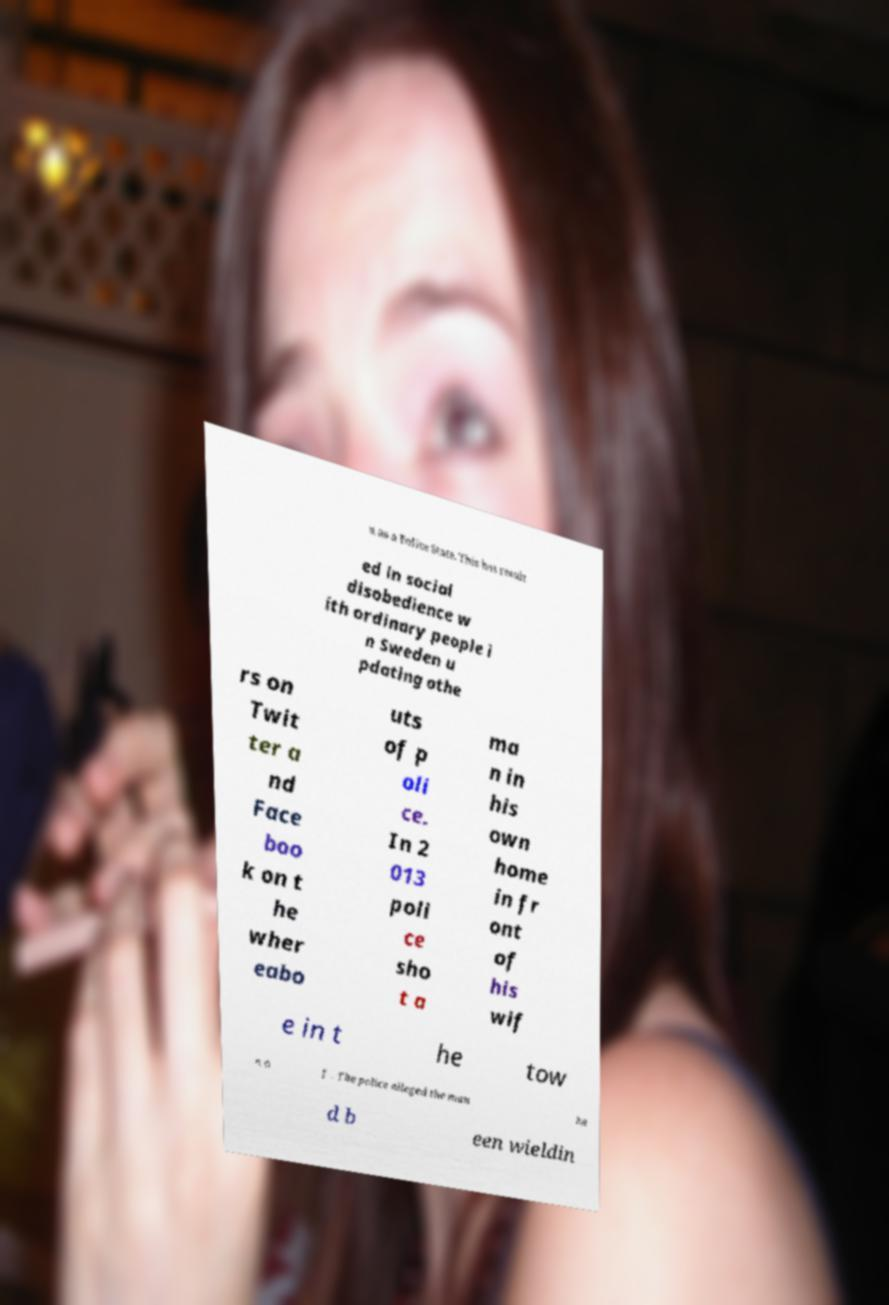Could you extract and type out the text from this image? n as a Police State. This has result ed in social disobedience w ith ordinary people i n Sweden u pdating othe rs on Twit ter a nd Face boo k on t he wher eabo uts of p oli ce. In 2 013 poli ce sho t a ma n in his own home in fr ont of his wif e in t he tow n o f . The police alleged the man ha d b een wieldin 